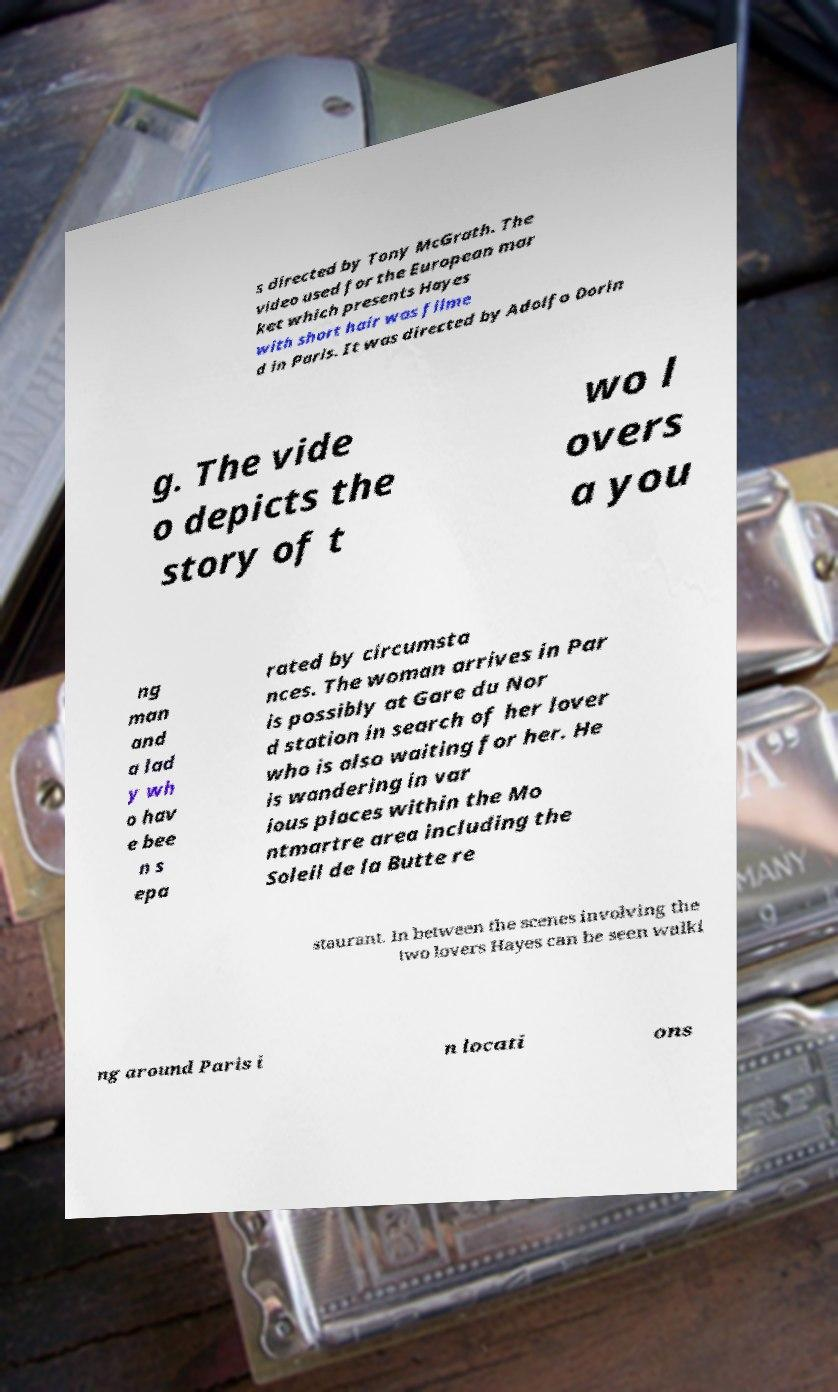Could you assist in decoding the text presented in this image and type it out clearly? s directed by Tony McGrath. The video used for the European mar ket which presents Hayes with short hair was filme d in Paris. It was directed by Adolfo Dorin g. The vide o depicts the story of t wo l overs a you ng man and a lad y wh o hav e bee n s epa rated by circumsta nces. The woman arrives in Par is possibly at Gare du Nor d station in search of her lover who is also waiting for her. He is wandering in var ious places within the Mo ntmartre area including the Soleil de la Butte re staurant. In between the scenes involving the two lovers Hayes can be seen walki ng around Paris i n locati ons 